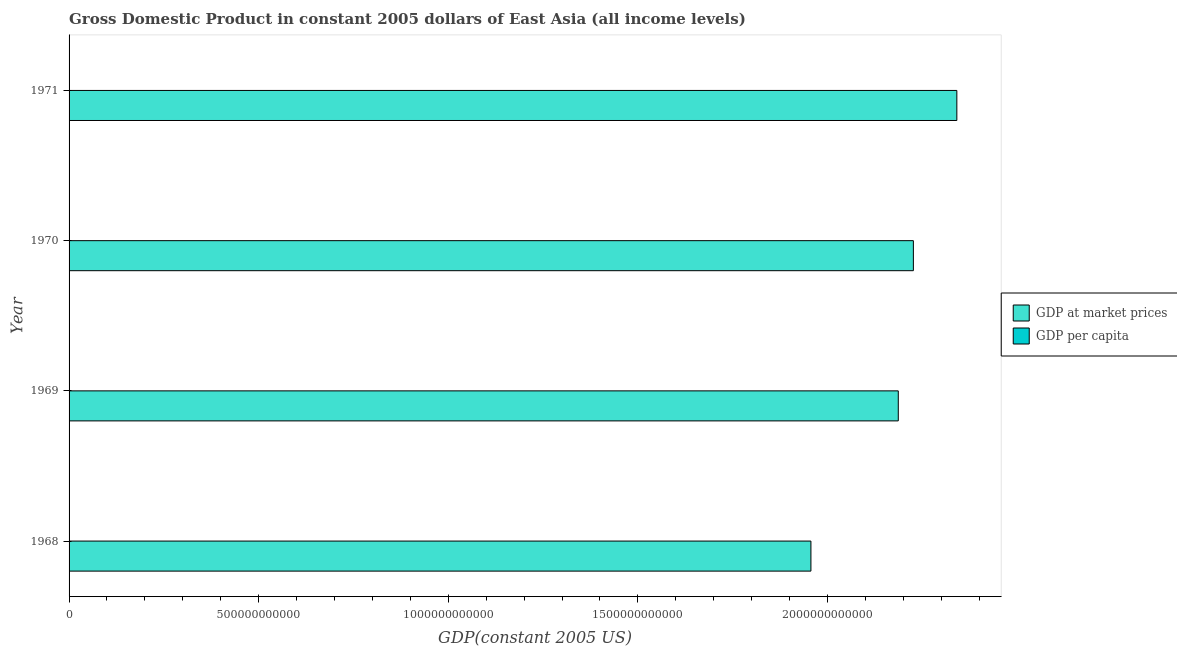How many groups of bars are there?
Your response must be concise. 4. How many bars are there on the 4th tick from the bottom?
Your answer should be compact. 2. In how many cases, is the number of bars for a given year not equal to the number of legend labels?
Your answer should be very brief. 0. What is the gdp per capita in 1971?
Your answer should be compact. 1769.64. Across all years, what is the maximum gdp per capita?
Ensure brevity in your answer.  1769.64. Across all years, what is the minimum gdp per capita?
Your answer should be very brief. 1598.32. In which year was the gdp per capita maximum?
Ensure brevity in your answer.  1971. In which year was the gdp at market prices minimum?
Your answer should be very brief. 1968. What is the total gdp at market prices in the graph?
Offer a very short reply. 8.71e+12. What is the difference between the gdp per capita in 1968 and that in 1971?
Offer a very short reply. -171.32. What is the difference between the gdp at market prices in 1971 and the gdp per capita in 1969?
Your answer should be compact. 2.34e+12. What is the average gdp at market prices per year?
Offer a terse response. 2.18e+12. In the year 1969, what is the difference between the gdp per capita and gdp at market prices?
Offer a terse response. -2.19e+12. What is the ratio of the gdp at market prices in 1968 to that in 1971?
Your answer should be compact. 0.84. Is the gdp at market prices in 1968 less than that in 1970?
Your answer should be very brief. Yes. Is the difference between the gdp per capita in 1968 and 1971 greater than the difference between the gdp at market prices in 1968 and 1971?
Offer a terse response. Yes. What is the difference between the highest and the second highest gdp at market prices?
Provide a succinct answer. 1.15e+11. What is the difference between the highest and the lowest gdp at market prices?
Make the answer very short. 3.85e+11. Is the sum of the gdp per capita in 1969 and 1971 greater than the maximum gdp at market prices across all years?
Make the answer very short. No. What does the 2nd bar from the top in 1968 represents?
Your response must be concise. GDP at market prices. What does the 2nd bar from the bottom in 1969 represents?
Make the answer very short. GDP per capita. How many years are there in the graph?
Keep it short and to the point. 4. What is the difference between two consecutive major ticks on the X-axis?
Your answer should be compact. 5.00e+11. Are the values on the major ticks of X-axis written in scientific E-notation?
Offer a very short reply. No. Where does the legend appear in the graph?
Provide a short and direct response. Center right. How are the legend labels stacked?
Keep it short and to the point. Vertical. What is the title of the graph?
Offer a very short reply. Gross Domestic Product in constant 2005 dollars of East Asia (all income levels). Does "Domestic liabilities" appear as one of the legend labels in the graph?
Your answer should be very brief. No. What is the label or title of the X-axis?
Your answer should be compact. GDP(constant 2005 US). What is the label or title of the Y-axis?
Keep it short and to the point. Year. What is the GDP(constant 2005 US) of GDP at market prices in 1968?
Make the answer very short. 1.96e+12. What is the GDP(constant 2005 US) in GDP per capita in 1968?
Provide a short and direct response. 1598.32. What is the GDP(constant 2005 US) in GDP at market prices in 1969?
Give a very brief answer. 2.19e+12. What is the GDP(constant 2005 US) in GDP per capita in 1969?
Keep it short and to the point. 1740.14. What is the GDP(constant 2005 US) in GDP at market prices in 1970?
Your answer should be very brief. 2.23e+12. What is the GDP(constant 2005 US) of GDP per capita in 1970?
Provide a short and direct response. 1726.92. What is the GDP(constant 2005 US) of GDP at market prices in 1971?
Give a very brief answer. 2.34e+12. What is the GDP(constant 2005 US) of GDP per capita in 1971?
Your answer should be very brief. 1769.64. Across all years, what is the maximum GDP(constant 2005 US) of GDP at market prices?
Make the answer very short. 2.34e+12. Across all years, what is the maximum GDP(constant 2005 US) in GDP per capita?
Provide a succinct answer. 1769.64. Across all years, what is the minimum GDP(constant 2005 US) of GDP at market prices?
Provide a short and direct response. 1.96e+12. Across all years, what is the minimum GDP(constant 2005 US) in GDP per capita?
Your response must be concise. 1598.32. What is the total GDP(constant 2005 US) in GDP at market prices in the graph?
Make the answer very short. 8.71e+12. What is the total GDP(constant 2005 US) in GDP per capita in the graph?
Your response must be concise. 6835.03. What is the difference between the GDP(constant 2005 US) in GDP at market prices in 1968 and that in 1969?
Provide a succinct answer. -2.30e+11. What is the difference between the GDP(constant 2005 US) in GDP per capita in 1968 and that in 1969?
Your response must be concise. -141.82. What is the difference between the GDP(constant 2005 US) of GDP at market prices in 1968 and that in 1970?
Your answer should be compact. -2.70e+11. What is the difference between the GDP(constant 2005 US) of GDP per capita in 1968 and that in 1970?
Provide a succinct answer. -128.6. What is the difference between the GDP(constant 2005 US) in GDP at market prices in 1968 and that in 1971?
Your answer should be compact. -3.85e+11. What is the difference between the GDP(constant 2005 US) in GDP per capita in 1968 and that in 1971?
Provide a short and direct response. -171.32. What is the difference between the GDP(constant 2005 US) of GDP at market prices in 1969 and that in 1970?
Your response must be concise. -3.98e+1. What is the difference between the GDP(constant 2005 US) of GDP per capita in 1969 and that in 1970?
Ensure brevity in your answer.  13.23. What is the difference between the GDP(constant 2005 US) in GDP at market prices in 1969 and that in 1971?
Make the answer very short. -1.54e+11. What is the difference between the GDP(constant 2005 US) of GDP per capita in 1969 and that in 1971?
Ensure brevity in your answer.  -29.5. What is the difference between the GDP(constant 2005 US) in GDP at market prices in 1970 and that in 1971?
Make the answer very short. -1.15e+11. What is the difference between the GDP(constant 2005 US) in GDP per capita in 1970 and that in 1971?
Your response must be concise. -42.73. What is the difference between the GDP(constant 2005 US) in GDP at market prices in 1968 and the GDP(constant 2005 US) in GDP per capita in 1969?
Provide a succinct answer. 1.96e+12. What is the difference between the GDP(constant 2005 US) in GDP at market prices in 1968 and the GDP(constant 2005 US) in GDP per capita in 1970?
Provide a succinct answer. 1.96e+12. What is the difference between the GDP(constant 2005 US) in GDP at market prices in 1968 and the GDP(constant 2005 US) in GDP per capita in 1971?
Your answer should be compact. 1.96e+12. What is the difference between the GDP(constant 2005 US) in GDP at market prices in 1969 and the GDP(constant 2005 US) in GDP per capita in 1970?
Your answer should be very brief. 2.19e+12. What is the difference between the GDP(constant 2005 US) in GDP at market prices in 1969 and the GDP(constant 2005 US) in GDP per capita in 1971?
Offer a very short reply. 2.19e+12. What is the difference between the GDP(constant 2005 US) of GDP at market prices in 1970 and the GDP(constant 2005 US) of GDP per capita in 1971?
Provide a succinct answer. 2.23e+12. What is the average GDP(constant 2005 US) in GDP at market prices per year?
Your response must be concise. 2.18e+12. What is the average GDP(constant 2005 US) of GDP per capita per year?
Your answer should be compact. 1708.76. In the year 1968, what is the difference between the GDP(constant 2005 US) in GDP at market prices and GDP(constant 2005 US) in GDP per capita?
Make the answer very short. 1.96e+12. In the year 1969, what is the difference between the GDP(constant 2005 US) in GDP at market prices and GDP(constant 2005 US) in GDP per capita?
Your answer should be compact. 2.19e+12. In the year 1970, what is the difference between the GDP(constant 2005 US) of GDP at market prices and GDP(constant 2005 US) of GDP per capita?
Ensure brevity in your answer.  2.23e+12. In the year 1971, what is the difference between the GDP(constant 2005 US) in GDP at market prices and GDP(constant 2005 US) in GDP per capita?
Offer a very short reply. 2.34e+12. What is the ratio of the GDP(constant 2005 US) of GDP at market prices in 1968 to that in 1969?
Ensure brevity in your answer.  0.89. What is the ratio of the GDP(constant 2005 US) in GDP per capita in 1968 to that in 1969?
Offer a very short reply. 0.92. What is the ratio of the GDP(constant 2005 US) in GDP at market prices in 1968 to that in 1970?
Provide a succinct answer. 0.88. What is the ratio of the GDP(constant 2005 US) of GDP per capita in 1968 to that in 1970?
Your response must be concise. 0.93. What is the ratio of the GDP(constant 2005 US) of GDP at market prices in 1968 to that in 1971?
Your answer should be very brief. 0.84. What is the ratio of the GDP(constant 2005 US) of GDP per capita in 1968 to that in 1971?
Offer a very short reply. 0.9. What is the ratio of the GDP(constant 2005 US) in GDP at market prices in 1969 to that in 1970?
Make the answer very short. 0.98. What is the ratio of the GDP(constant 2005 US) of GDP per capita in 1969 to that in 1970?
Provide a short and direct response. 1.01. What is the ratio of the GDP(constant 2005 US) of GDP at market prices in 1969 to that in 1971?
Offer a terse response. 0.93. What is the ratio of the GDP(constant 2005 US) in GDP per capita in 1969 to that in 1971?
Your response must be concise. 0.98. What is the ratio of the GDP(constant 2005 US) of GDP at market prices in 1970 to that in 1971?
Provide a succinct answer. 0.95. What is the ratio of the GDP(constant 2005 US) of GDP per capita in 1970 to that in 1971?
Ensure brevity in your answer.  0.98. What is the difference between the highest and the second highest GDP(constant 2005 US) in GDP at market prices?
Your answer should be compact. 1.15e+11. What is the difference between the highest and the second highest GDP(constant 2005 US) in GDP per capita?
Make the answer very short. 29.5. What is the difference between the highest and the lowest GDP(constant 2005 US) in GDP at market prices?
Offer a terse response. 3.85e+11. What is the difference between the highest and the lowest GDP(constant 2005 US) in GDP per capita?
Ensure brevity in your answer.  171.32. 